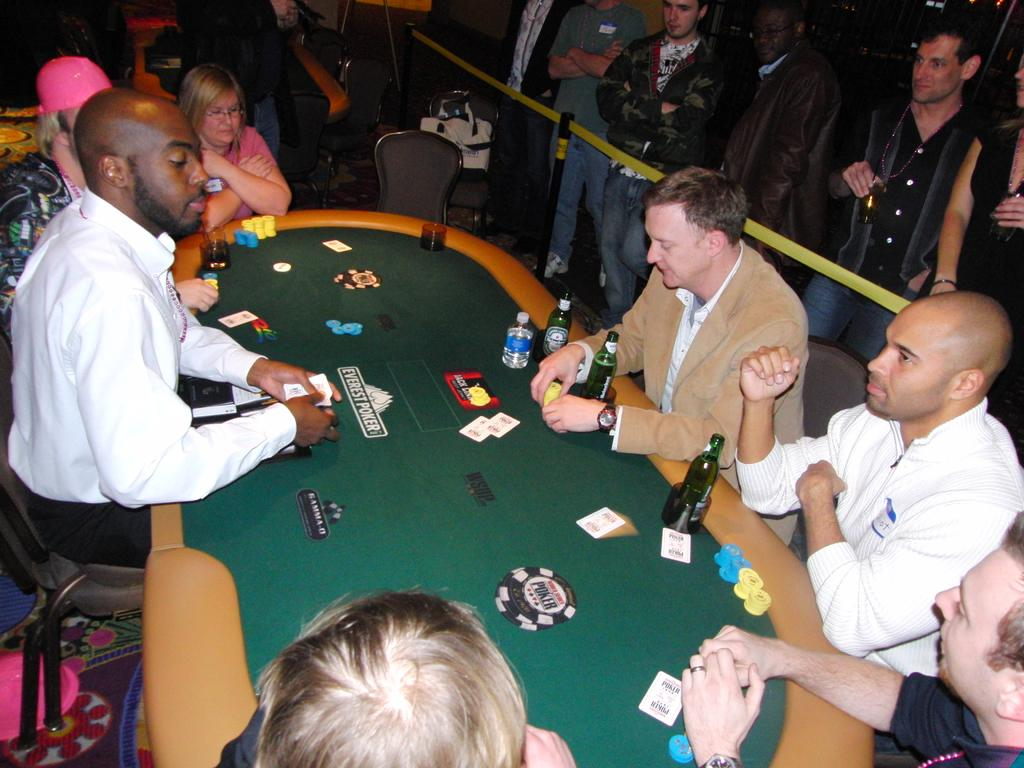How many people are in the image? There is a group of people in the image, but the exact number is not specified. What are some of the people in the image doing? Some people are seated on chairs, while others are standing. What objects can be seen on the table in the image? There are bottles and cards on the table. What type of current can be seen flowing through the potato in the image? There is no potato or current present in the image. 